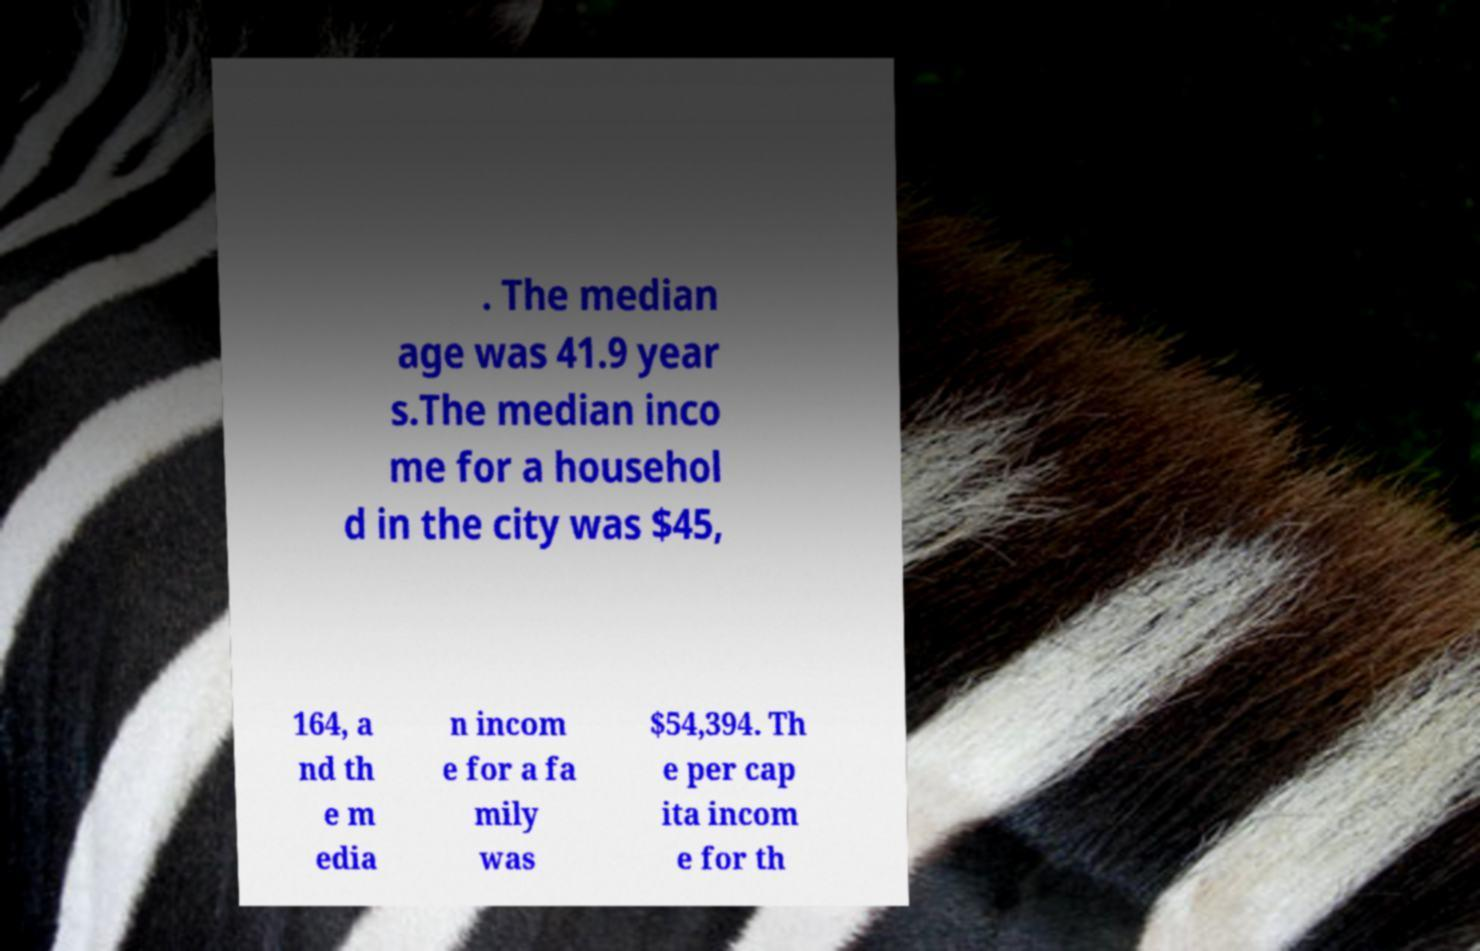There's text embedded in this image that I need extracted. Can you transcribe it verbatim? . The median age was 41.9 year s.The median inco me for a househol d in the city was $45, 164, a nd th e m edia n incom e for a fa mily was $54,394. Th e per cap ita incom e for th 